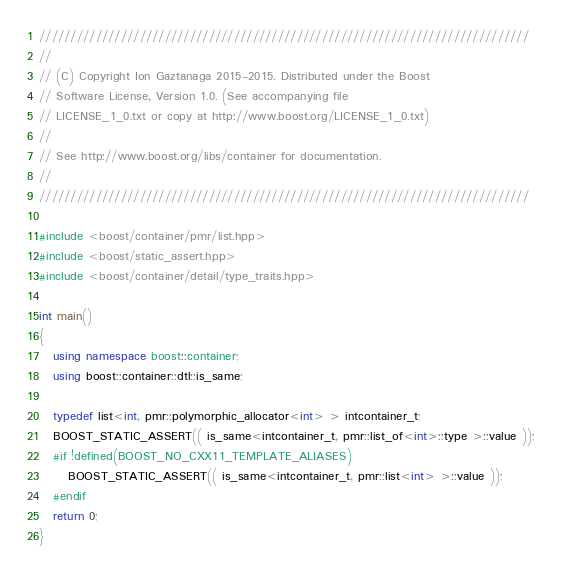<code> <loc_0><loc_0><loc_500><loc_500><_C++_>//////////////////////////////////////////////////////////////////////////////
//
// (C) Copyright Ion Gaztanaga 2015-2015. Distributed under the Boost
// Software License, Version 1.0. (See accompanying file
// LICENSE_1_0.txt or copy at http://www.boost.org/LICENSE_1_0.txt)
//
// See http://www.boost.org/libs/container for documentation.
//
//////////////////////////////////////////////////////////////////////////////

#include <boost/container/pmr/list.hpp>
#include <boost/static_assert.hpp>
#include <boost/container/detail/type_traits.hpp>

int main()
{
   using namespace boost::container;
   using boost::container::dtl::is_same;

   typedef list<int, pmr::polymorphic_allocator<int> > intcontainer_t;
   BOOST_STATIC_ASSERT(( is_same<intcontainer_t, pmr::list_of<int>::type >::value ));
   #if !defined(BOOST_NO_CXX11_TEMPLATE_ALIASES)
      BOOST_STATIC_ASSERT(( is_same<intcontainer_t, pmr::list<int> >::value ));
   #endif
   return 0;
}
</code> 